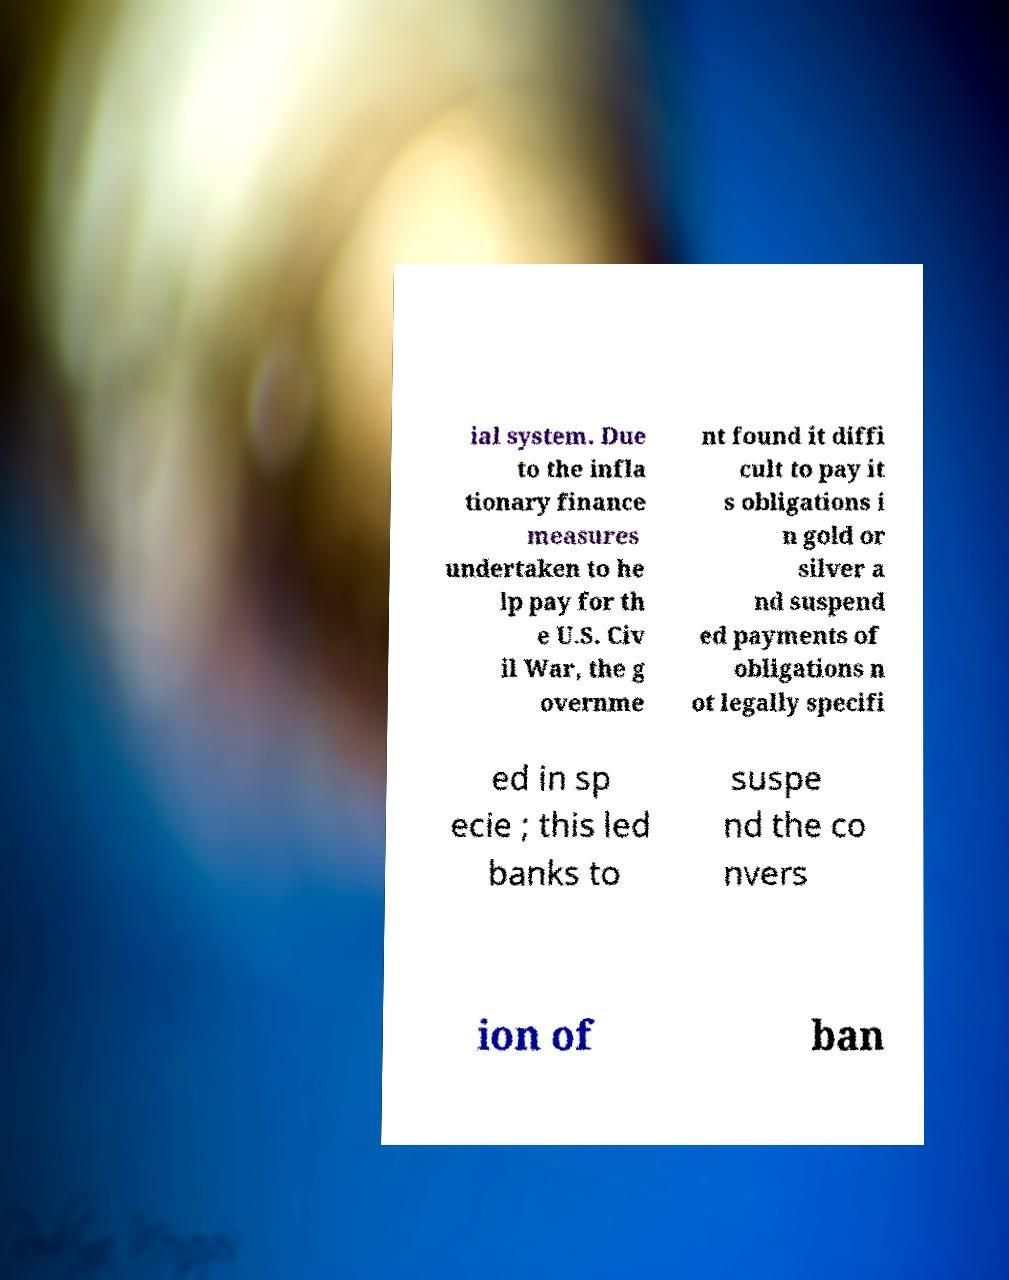Can you read and provide the text displayed in the image?This photo seems to have some interesting text. Can you extract and type it out for me? ial system. Due to the infla tionary finance measures undertaken to he lp pay for th e U.S. Civ il War, the g overnme nt found it diffi cult to pay it s obligations i n gold or silver a nd suspend ed payments of obligations n ot legally specifi ed in sp ecie ; this led banks to suspe nd the co nvers ion of ban 